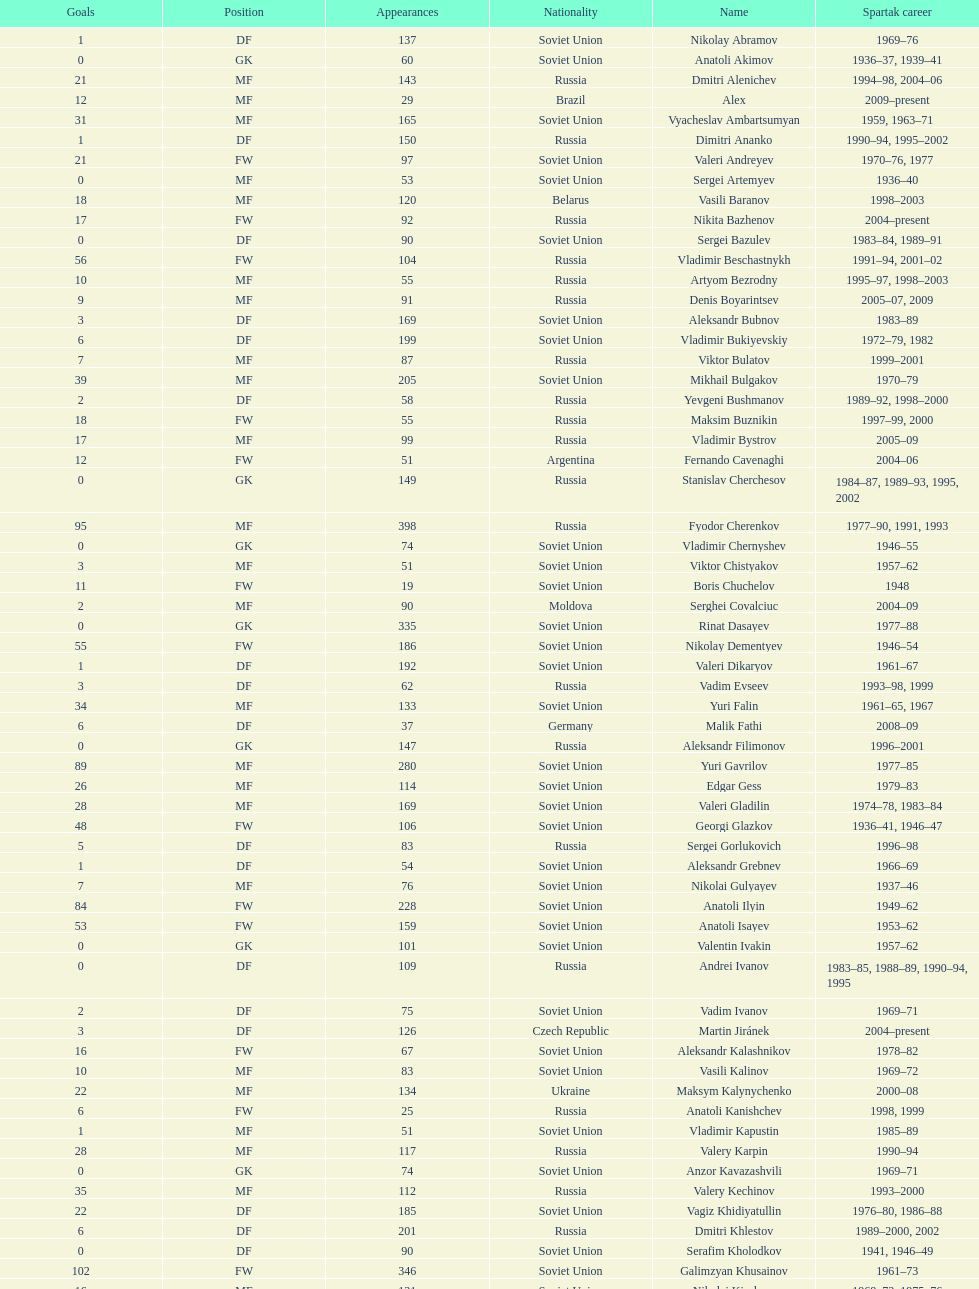Who had the highest number of appearances? Fyodor Cherenkov. 